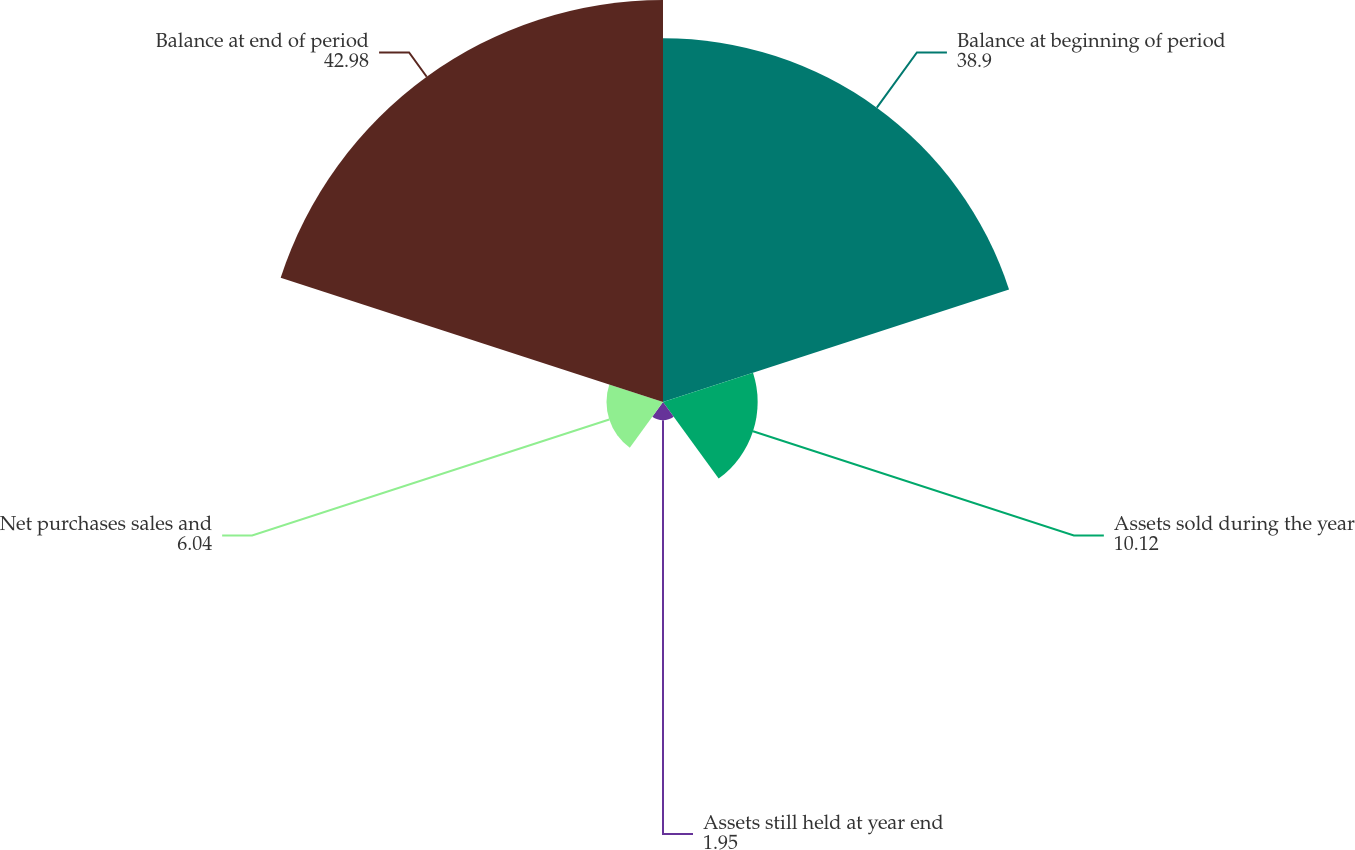Convert chart to OTSL. <chart><loc_0><loc_0><loc_500><loc_500><pie_chart><fcel>Balance at beginning of period<fcel>Assets sold during the year<fcel>Assets still held at year end<fcel>Net purchases sales and<fcel>Balance at end of period<nl><fcel>38.9%<fcel>10.12%<fcel>1.95%<fcel>6.04%<fcel>42.98%<nl></chart> 